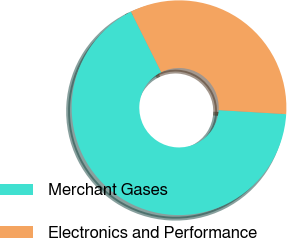Convert chart. <chart><loc_0><loc_0><loc_500><loc_500><pie_chart><fcel>Merchant Gases<fcel>Electronics and Performance<nl><fcel>66.67%<fcel>33.33%<nl></chart> 